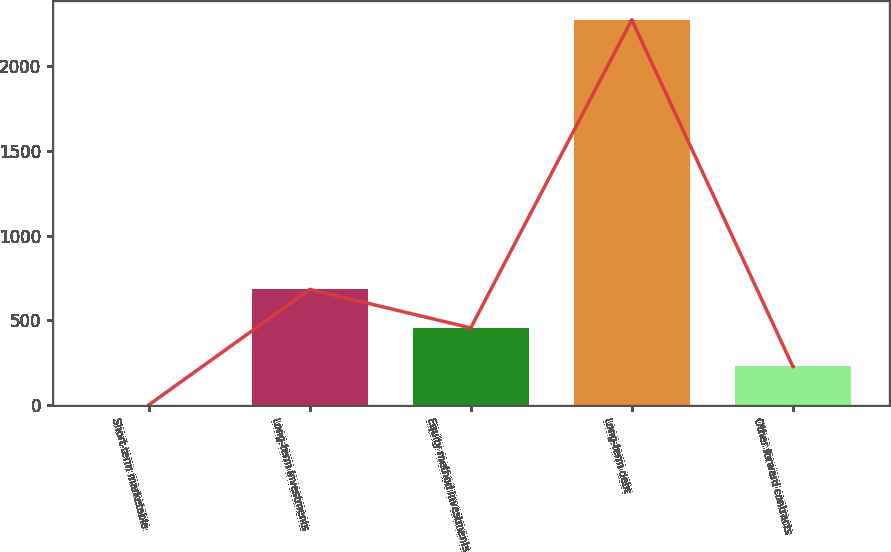Convert chart. <chart><loc_0><loc_0><loc_500><loc_500><bar_chart><fcel>Short-term marketable<fcel>Long-term investments<fcel>Equity method investments<fcel>Long-term debt<fcel>Other forward contracts<nl><fcel>1.4<fcel>683.54<fcel>456.16<fcel>2275.2<fcel>228.78<nl></chart> 